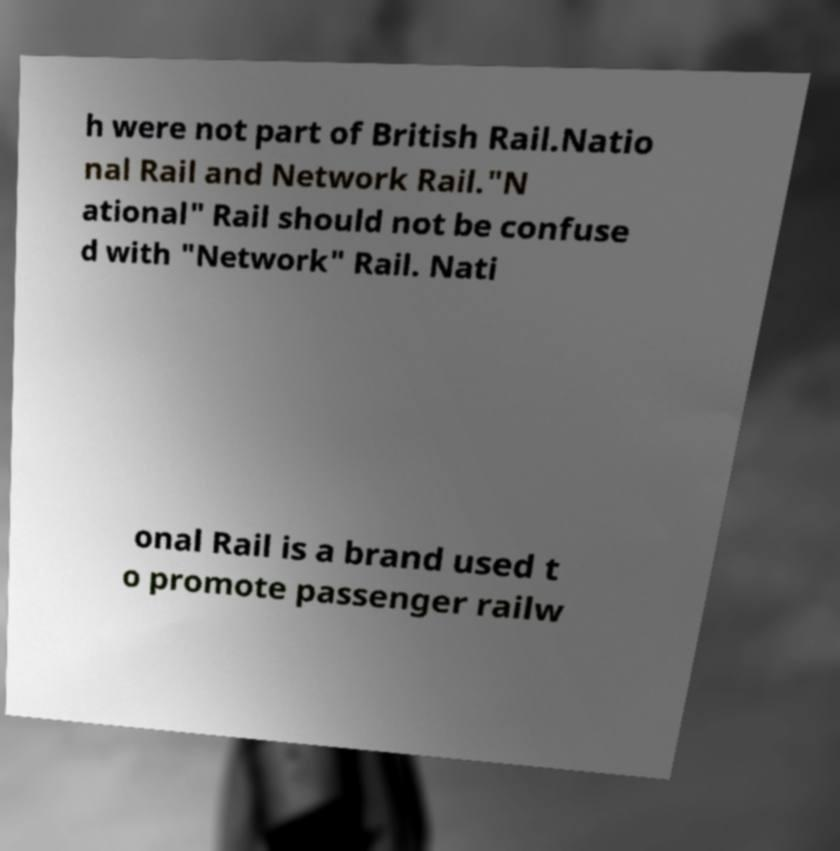What messages or text are displayed in this image? I need them in a readable, typed format. h were not part of British Rail.Natio nal Rail and Network Rail."N ational" Rail should not be confuse d with "Network" Rail. Nati onal Rail is a brand used t o promote passenger railw 